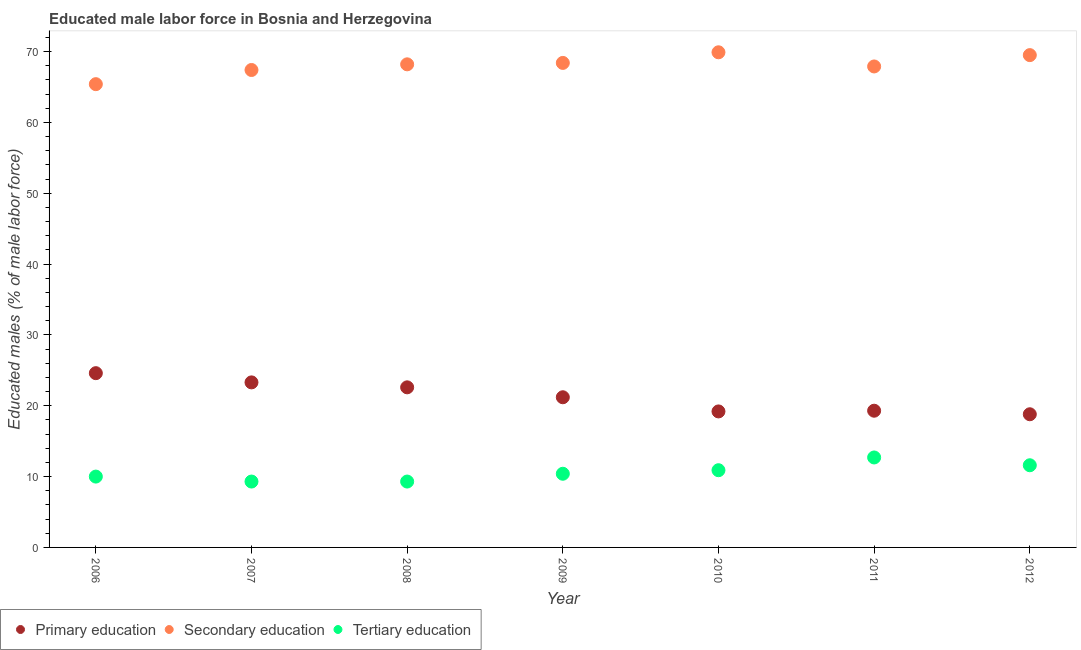How many different coloured dotlines are there?
Keep it short and to the point. 3. Is the number of dotlines equal to the number of legend labels?
Keep it short and to the point. Yes. What is the percentage of male labor force who received secondary education in 2006?
Provide a short and direct response. 65.4. Across all years, what is the maximum percentage of male labor force who received primary education?
Your answer should be very brief. 24.6. Across all years, what is the minimum percentage of male labor force who received secondary education?
Provide a succinct answer. 65.4. What is the total percentage of male labor force who received tertiary education in the graph?
Provide a short and direct response. 74.2. What is the difference between the percentage of male labor force who received secondary education in 2011 and that in 2012?
Your answer should be compact. -1.6. What is the difference between the percentage of male labor force who received secondary education in 2011 and the percentage of male labor force who received primary education in 2010?
Provide a short and direct response. 48.7. What is the average percentage of male labor force who received tertiary education per year?
Your answer should be compact. 10.6. In the year 2010, what is the difference between the percentage of male labor force who received secondary education and percentage of male labor force who received tertiary education?
Your response must be concise. 59. What is the ratio of the percentage of male labor force who received tertiary education in 2007 to that in 2012?
Make the answer very short. 0.8. What is the difference between the highest and the second highest percentage of male labor force who received primary education?
Give a very brief answer. 1.3. What is the difference between the highest and the lowest percentage of male labor force who received tertiary education?
Your answer should be very brief. 3.4. In how many years, is the percentage of male labor force who received tertiary education greater than the average percentage of male labor force who received tertiary education taken over all years?
Your response must be concise. 3. Is the percentage of male labor force who received secondary education strictly greater than the percentage of male labor force who received tertiary education over the years?
Your answer should be very brief. Yes. Is the percentage of male labor force who received primary education strictly less than the percentage of male labor force who received secondary education over the years?
Offer a very short reply. Yes. How many years are there in the graph?
Ensure brevity in your answer.  7. Does the graph contain grids?
Your answer should be very brief. No. Where does the legend appear in the graph?
Your answer should be very brief. Bottom left. How many legend labels are there?
Keep it short and to the point. 3. How are the legend labels stacked?
Offer a terse response. Horizontal. What is the title of the graph?
Ensure brevity in your answer.  Educated male labor force in Bosnia and Herzegovina. What is the label or title of the Y-axis?
Keep it short and to the point. Educated males (% of male labor force). What is the Educated males (% of male labor force) in Primary education in 2006?
Offer a terse response. 24.6. What is the Educated males (% of male labor force) in Secondary education in 2006?
Give a very brief answer. 65.4. What is the Educated males (% of male labor force) in Primary education in 2007?
Provide a short and direct response. 23.3. What is the Educated males (% of male labor force) in Secondary education in 2007?
Make the answer very short. 67.4. What is the Educated males (% of male labor force) of Tertiary education in 2007?
Make the answer very short. 9.3. What is the Educated males (% of male labor force) of Primary education in 2008?
Your response must be concise. 22.6. What is the Educated males (% of male labor force) in Secondary education in 2008?
Provide a short and direct response. 68.2. What is the Educated males (% of male labor force) of Tertiary education in 2008?
Provide a short and direct response. 9.3. What is the Educated males (% of male labor force) in Primary education in 2009?
Offer a terse response. 21.2. What is the Educated males (% of male labor force) of Secondary education in 2009?
Give a very brief answer. 68.4. What is the Educated males (% of male labor force) of Tertiary education in 2009?
Give a very brief answer. 10.4. What is the Educated males (% of male labor force) of Primary education in 2010?
Make the answer very short. 19.2. What is the Educated males (% of male labor force) of Secondary education in 2010?
Ensure brevity in your answer.  69.9. What is the Educated males (% of male labor force) of Tertiary education in 2010?
Keep it short and to the point. 10.9. What is the Educated males (% of male labor force) of Primary education in 2011?
Ensure brevity in your answer.  19.3. What is the Educated males (% of male labor force) in Secondary education in 2011?
Give a very brief answer. 67.9. What is the Educated males (% of male labor force) in Tertiary education in 2011?
Keep it short and to the point. 12.7. What is the Educated males (% of male labor force) of Primary education in 2012?
Your answer should be compact. 18.8. What is the Educated males (% of male labor force) in Secondary education in 2012?
Give a very brief answer. 69.5. What is the Educated males (% of male labor force) in Tertiary education in 2012?
Provide a succinct answer. 11.6. Across all years, what is the maximum Educated males (% of male labor force) in Primary education?
Make the answer very short. 24.6. Across all years, what is the maximum Educated males (% of male labor force) in Secondary education?
Keep it short and to the point. 69.9. Across all years, what is the maximum Educated males (% of male labor force) of Tertiary education?
Make the answer very short. 12.7. Across all years, what is the minimum Educated males (% of male labor force) of Primary education?
Keep it short and to the point. 18.8. Across all years, what is the minimum Educated males (% of male labor force) of Secondary education?
Your answer should be very brief. 65.4. Across all years, what is the minimum Educated males (% of male labor force) of Tertiary education?
Keep it short and to the point. 9.3. What is the total Educated males (% of male labor force) in Primary education in the graph?
Provide a short and direct response. 149. What is the total Educated males (% of male labor force) of Secondary education in the graph?
Offer a terse response. 476.7. What is the total Educated males (% of male labor force) of Tertiary education in the graph?
Your answer should be compact. 74.2. What is the difference between the Educated males (% of male labor force) of Tertiary education in 2006 and that in 2007?
Offer a terse response. 0.7. What is the difference between the Educated males (% of male labor force) of Primary education in 2006 and that in 2009?
Your answer should be compact. 3.4. What is the difference between the Educated males (% of male labor force) of Secondary education in 2006 and that in 2009?
Offer a terse response. -3. What is the difference between the Educated males (% of male labor force) in Tertiary education in 2006 and that in 2009?
Ensure brevity in your answer.  -0.4. What is the difference between the Educated males (% of male labor force) in Primary education in 2006 and that in 2010?
Your answer should be very brief. 5.4. What is the difference between the Educated males (% of male labor force) of Primary education in 2006 and that in 2011?
Provide a succinct answer. 5.3. What is the difference between the Educated males (% of male labor force) of Tertiary education in 2006 and that in 2011?
Provide a succinct answer. -2.7. What is the difference between the Educated males (% of male labor force) of Primary education in 2006 and that in 2012?
Make the answer very short. 5.8. What is the difference between the Educated males (% of male labor force) of Secondary education in 2006 and that in 2012?
Ensure brevity in your answer.  -4.1. What is the difference between the Educated males (% of male labor force) in Tertiary education in 2006 and that in 2012?
Provide a short and direct response. -1.6. What is the difference between the Educated males (% of male labor force) in Secondary education in 2007 and that in 2008?
Keep it short and to the point. -0.8. What is the difference between the Educated males (% of male labor force) of Tertiary education in 2007 and that in 2008?
Ensure brevity in your answer.  0. What is the difference between the Educated males (% of male labor force) of Secondary education in 2007 and that in 2009?
Your response must be concise. -1. What is the difference between the Educated males (% of male labor force) of Primary education in 2007 and that in 2010?
Your response must be concise. 4.1. What is the difference between the Educated males (% of male labor force) of Secondary education in 2007 and that in 2010?
Your response must be concise. -2.5. What is the difference between the Educated males (% of male labor force) in Tertiary education in 2007 and that in 2010?
Keep it short and to the point. -1.6. What is the difference between the Educated males (% of male labor force) of Primary education in 2007 and that in 2011?
Offer a terse response. 4. What is the difference between the Educated males (% of male labor force) of Primary education in 2007 and that in 2012?
Offer a terse response. 4.5. What is the difference between the Educated males (% of male labor force) of Secondary education in 2007 and that in 2012?
Offer a terse response. -2.1. What is the difference between the Educated males (% of male labor force) in Secondary education in 2008 and that in 2009?
Ensure brevity in your answer.  -0.2. What is the difference between the Educated males (% of male labor force) of Primary education in 2008 and that in 2012?
Your answer should be compact. 3.8. What is the difference between the Educated males (% of male labor force) of Secondary education in 2008 and that in 2012?
Give a very brief answer. -1.3. What is the difference between the Educated males (% of male labor force) of Secondary education in 2009 and that in 2010?
Keep it short and to the point. -1.5. What is the difference between the Educated males (% of male labor force) in Tertiary education in 2009 and that in 2010?
Offer a very short reply. -0.5. What is the difference between the Educated males (% of male labor force) of Tertiary education in 2009 and that in 2012?
Make the answer very short. -1.2. What is the difference between the Educated males (% of male labor force) of Tertiary education in 2010 and that in 2011?
Give a very brief answer. -1.8. What is the difference between the Educated males (% of male labor force) in Primary education in 2010 and that in 2012?
Keep it short and to the point. 0.4. What is the difference between the Educated males (% of male labor force) of Secondary education in 2010 and that in 2012?
Your response must be concise. 0.4. What is the difference between the Educated males (% of male labor force) in Tertiary education in 2010 and that in 2012?
Keep it short and to the point. -0.7. What is the difference between the Educated males (% of male labor force) of Primary education in 2006 and the Educated males (% of male labor force) of Secondary education in 2007?
Your answer should be very brief. -42.8. What is the difference between the Educated males (% of male labor force) in Primary education in 2006 and the Educated males (% of male labor force) in Tertiary education in 2007?
Provide a succinct answer. 15.3. What is the difference between the Educated males (% of male labor force) in Secondary education in 2006 and the Educated males (% of male labor force) in Tertiary education in 2007?
Your response must be concise. 56.1. What is the difference between the Educated males (% of male labor force) of Primary education in 2006 and the Educated males (% of male labor force) of Secondary education in 2008?
Keep it short and to the point. -43.6. What is the difference between the Educated males (% of male labor force) of Secondary education in 2006 and the Educated males (% of male labor force) of Tertiary education in 2008?
Your answer should be very brief. 56.1. What is the difference between the Educated males (% of male labor force) of Primary education in 2006 and the Educated males (% of male labor force) of Secondary education in 2009?
Give a very brief answer. -43.8. What is the difference between the Educated males (% of male labor force) of Primary education in 2006 and the Educated males (% of male labor force) of Tertiary education in 2009?
Offer a terse response. 14.2. What is the difference between the Educated males (% of male labor force) in Secondary education in 2006 and the Educated males (% of male labor force) in Tertiary education in 2009?
Give a very brief answer. 55. What is the difference between the Educated males (% of male labor force) in Primary education in 2006 and the Educated males (% of male labor force) in Secondary education in 2010?
Keep it short and to the point. -45.3. What is the difference between the Educated males (% of male labor force) of Primary education in 2006 and the Educated males (% of male labor force) of Tertiary education in 2010?
Provide a succinct answer. 13.7. What is the difference between the Educated males (% of male labor force) of Secondary education in 2006 and the Educated males (% of male labor force) of Tertiary education in 2010?
Provide a short and direct response. 54.5. What is the difference between the Educated males (% of male labor force) of Primary education in 2006 and the Educated males (% of male labor force) of Secondary education in 2011?
Make the answer very short. -43.3. What is the difference between the Educated males (% of male labor force) of Secondary education in 2006 and the Educated males (% of male labor force) of Tertiary education in 2011?
Provide a short and direct response. 52.7. What is the difference between the Educated males (% of male labor force) of Primary education in 2006 and the Educated males (% of male labor force) of Secondary education in 2012?
Make the answer very short. -44.9. What is the difference between the Educated males (% of male labor force) in Secondary education in 2006 and the Educated males (% of male labor force) in Tertiary education in 2012?
Offer a terse response. 53.8. What is the difference between the Educated males (% of male labor force) of Primary education in 2007 and the Educated males (% of male labor force) of Secondary education in 2008?
Your answer should be compact. -44.9. What is the difference between the Educated males (% of male labor force) of Secondary education in 2007 and the Educated males (% of male labor force) of Tertiary education in 2008?
Your answer should be very brief. 58.1. What is the difference between the Educated males (% of male labor force) of Primary education in 2007 and the Educated males (% of male labor force) of Secondary education in 2009?
Give a very brief answer. -45.1. What is the difference between the Educated males (% of male labor force) in Primary education in 2007 and the Educated males (% of male labor force) in Tertiary education in 2009?
Give a very brief answer. 12.9. What is the difference between the Educated males (% of male labor force) in Secondary education in 2007 and the Educated males (% of male labor force) in Tertiary education in 2009?
Offer a very short reply. 57. What is the difference between the Educated males (% of male labor force) of Primary education in 2007 and the Educated males (% of male labor force) of Secondary education in 2010?
Provide a succinct answer. -46.6. What is the difference between the Educated males (% of male labor force) of Primary education in 2007 and the Educated males (% of male labor force) of Tertiary education in 2010?
Offer a terse response. 12.4. What is the difference between the Educated males (% of male labor force) of Secondary education in 2007 and the Educated males (% of male labor force) of Tertiary education in 2010?
Provide a short and direct response. 56.5. What is the difference between the Educated males (% of male labor force) in Primary education in 2007 and the Educated males (% of male labor force) in Secondary education in 2011?
Your answer should be very brief. -44.6. What is the difference between the Educated males (% of male labor force) in Primary education in 2007 and the Educated males (% of male labor force) in Tertiary education in 2011?
Provide a short and direct response. 10.6. What is the difference between the Educated males (% of male labor force) in Secondary education in 2007 and the Educated males (% of male labor force) in Tertiary education in 2011?
Give a very brief answer. 54.7. What is the difference between the Educated males (% of male labor force) in Primary education in 2007 and the Educated males (% of male labor force) in Secondary education in 2012?
Your answer should be compact. -46.2. What is the difference between the Educated males (% of male labor force) of Secondary education in 2007 and the Educated males (% of male labor force) of Tertiary education in 2012?
Provide a short and direct response. 55.8. What is the difference between the Educated males (% of male labor force) in Primary education in 2008 and the Educated males (% of male labor force) in Secondary education in 2009?
Offer a very short reply. -45.8. What is the difference between the Educated males (% of male labor force) of Secondary education in 2008 and the Educated males (% of male labor force) of Tertiary education in 2009?
Ensure brevity in your answer.  57.8. What is the difference between the Educated males (% of male labor force) in Primary education in 2008 and the Educated males (% of male labor force) in Secondary education in 2010?
Make the answer very short. -47.3. What is the difference between the Educated males (% of male labor force) of Primary education in 2008 and the Educated males (% of male labor force) of Tertiary education in 2010?
Your answer should be very brief. 11.7. What is the difference between the Educated males (% of male labor force) in Secondary education in 2008 and the Educated males (% of male labor force) in Tertiary education in 2010?
Offer a terse response. 57.3. What is the difference between the Educated males (% of male labor force) of Primary education in 2008 and the Educated males (% of male labor force) of Secondary education in 2011?
Provide a succinct answer. -45.3. What is the difference between the Educated males (% of male labor force) in Secondary education in 2008 and the Educated males (% of male labor force) in Tertiary education in 2011?
Ensure brevity in your answer.  55.5. What is the difference between the Educated males (% of male labor force) in Primary education in 2008 and the Educated males (% of male labor force) in Secondary education in 2012?
Offer a terse response. -46.9. What is the difference between the Educated males (% of male labor force) of Primary education in 2008 and the Educated males (% of male labor force) of Tertiary education in 2012?
Offer a terse response. 11. What is the difference between the Educated males (% of male labor force) in Secondary education in 2008 and the Educated males (% of male labor force) in Tertiary education in 2012?
Your answer should be compact. 56.6. What is the difference between the Educated males (% of male labor force) in Primary education in 2009 and the Educated males (% of male labor force) in Secondary education in 2010?
Provide a short and direct response. -48.7. What is the difference between the Educated males (% of male labor force) of Secondary education in 2009 and the Educated males (% of male labor force) of Tertiary education in 2010?
Provide a short and direct response. 57.5. What is the difference between the Educated males (% of male labor force) of Primary education in 2009 and the Educated males (% of male labor force) of Secondary education in 2011?
Give a very brief answer. -46.7. What is the difference between the Educated males (% of male labor force) in Secondary education in 2009 and the Educated males (% of male labor force) in Tertiary education in 2011?
Make the answer very short. 55.7. What is the difference between the Educated males (% of male labor force) in Primary education in 2009 and the Educated males (% of male labor force) in Secondary education in 2012?
Provide a succinct answer. -48.3. What is the difference between the Educated males (% of male labor force) in Secondary education in 2009 and the Educated males (% of male labor force) in Tertiary education in 2012?
Provide a succinct answer. 56.8. What is the difference between the Educated males (% of male labor force) in Primary education in 2010 and the Educated males (% of male labor force) in Secondary education in 2011?
Your answer should be very brief. -48.7. What is the difference between the Educated males (% of male labor force) of Primary education in 2010 and the Educated males (% of male labor force) of Tertiary education in 2011?
Give a very brief answer. 6.5. What is the difference between the Educated males (% of male labor force) of Secondary education in 2010 and the Educated males (% of male labor force) of Tertiary education in 2011?
Your answer should be very brief. 57.2. What is the difference between the Educated males (% of male labor force) in Primary education in 2010 and the Educated males (% of male labor force) in Secondary education in 2012?
Offer a terse response. -50.3. What is the difference between the Educated males (% of male labor force) in Primary education in 2010 and the Educated males (% of male labor force) in Tertiary education in 2012?
Offer a terse response. 7.6. What is the difference between the Educated males (% of male labor force) of Secondary education in 2010 and the Educated males (% of male labor force) of Tertiary education in 2012?
Your answer should be compact. 58.3. What is the difference between the Educated males (% of male labor force) of Primary education in 2011 and the Educated males (% of male labor force) of Secondary education in 2012?
Offer a terse response. -50.2. What is the difference between the Educated males (% of male labor force) in Secondary education in 2011 and the Educated males (% of male labor force) in Tertiary education in 2012?
Make the answer very short. 56.3. What is the average Educated males (% of male labor force) of Primary education per year?
Make the answer very short. 21.29. What is the average Educated males (% of male labor force) of Secondary education per year?
Your answer should be compact. 68.1. What is the average Educated males (% of male labor force) in Tertiary education per year?
Your response must be concise. 10.6. In the year 2006, what is the difference between the Educated males (% of male labor force) of Primary education and Educated males (% of male labor force) of Secondary education?
Your answer should be very brief. -40.8. In the year 2006, what is the difference between the Educated males (% of male labor force) of Secondary education and Educated males (% of male labor force) of Tertiary education?
Make the answer very short. 55.4. In the year 2007, what is the difference between the Educated males (% of male labor force) of Primary education and Educated males (% of male labor force) of Secondary education?
Provide a succinct answer. -44.1. In the year 2007, what is the difference between the Educated males (% of male labor force) in Primary education and Educated males (% of male labor force) in Tertiary education?
Ensure brevity in your answer.  14. In the year 2007, what is the difference between the Educated males (% of male labor force) of Secondary education and Educated males (% of male labor force) of Tertiary education?
Offer a very short reply. 58.1. In the year 2008, what is the difference between the Educated males (% of male labor force) in Primary education and Educated males (% of male labor force) in Secondary education?
Provide a succinct answer. -45.6. In the year 2008, what is the difference between the Educated males (% of male labor force) in Secondary education and Educated males (% of male labor force) in Tertiary education?
Provide a short and direct response. 58.9. In the year 2009, what is the difference between the Educated males (% of male labor force) in Primary education and Educated males (% of male labor force) in Secondary education?
Your answer should be compact. -47.2. In the year 2009, what is the difference between the Educated males (% of male labor force) of Primary education and Educated males (% of male labor force) of Tertiary education?
Your answer should be very brief. 10.8. In the year 2009, what is the difference between the Educated males (% of male labor force) of Secondary education and Educated males (% of male labor force) of Tertiary education?
Keep it short and to the point. 58. In the year 2010, what is the difference between the Educated males (% of male labor force) in Primary education and Educated males (% of male labor force) in Secondary education?
Ensure brevity in your answer.  -50.7. In the year 2010, what is the difference between the Educated males (% of male labor force) of Secondary education and Educated males (% of male labor force) of Tertiary education?
Ensure brevity in your answer.  59. In the year 2011, what is the difference between the Educated males (% of male labor force) in Primary education and Educated males (% of male labor force) in Secondary education?
Ensure brevity in your answer.  -48.6. In the year 2011, what is the difference between the Educated males (% of male labor force) in Secondary education and Educated males (% of male labor force) in Tertiary education?
Offer a very short reply. 55.2. In the year 2012, what is the difference between the Educated males (% of male labor force) in Primary education and Educated males (% of male labor force) in Secondary education?
Your answer should be compact. -50.7. In the year 2012, what is the difference between the Educated males (% of male labor force) of Primary education and Educated males (% of male labor force) of Tertiary education?
Your answer should be compact. 7.2. In the year 2012, what is the difference between the Educated males (% of male labor force) of Secondary education and Educated males (% of male labor force) of Tertiary education?
Your answer should be compact. 57.9. What is the ratio of the Educated males (% of male labor force) in Primary education in 2006 to that in 2007?
Your answer should be very brief. 1.06. What is the ratio of the Educated males (% of male labor force) of Secondary education in 2006 to that in 2007?
Keep it short and to the point. 0.97. What is the ratio of the Educated males (% of male labor force) in Tertiary education in 2006 to that in 2007?
Your response must be concise. 1.08. What is the ratio of the Educated males (% of male labor force) in Primary education in 2006 to that in 2008?
Your response must be concise. 1.09. What is the ratio of the Educated males (% of male labor force) in Secondary education in 2006 to that in 2008?
Provide a succinct answer. 0.96. What is the ratio of the Educated males (% of male labor force) in Tertiary education in 2006 to that in 2008?
Your response must be concise. 1.08. What is the ratio of the Educated males (% of male labor force) of Primary education in 2006 to that in 2009?
Offer a very short reply. 1.16. What is the ratio of the Educated males (% of male labor force) of Secondary education in 2006 to that in 2009?
Give a very brief answer. 0.96. What is the ratio of the Educated males (% of male labor force) in Tertiary education in 2006 to that in 2009?
Your response must be concise. 0.96. What is the ratio of the Educated males (% of male labor force) in Primary education in 2006 to that in 2010?
Provide a succinct answer. 1.28. What is the ratio of the Educated males (% of male labor force) in Secondary education in 2006 to that in 2010?
Make the answer very short. 0.94. What is the ratio of the Educated males (% of male labor force) in Tertiary education in 2006 to that in 2010?
Ensure brevity in your answer.  0.92. What is the ratio of the Educated males (% of male labor force) of Primary education in 2006 to that in 2011?
Make the answer very short. 1.27. What is the ratio of the Educated males (% of male labor force) of Secondary education in 2006 to that in 2011?
Your answer should be compact. 0.96. What is the ratio of the Educated males (% of male labor force) of Tertiary education in 2006 to that in 2011?
Keep it short and to the point. 0.79. What is the ratio of the Educated males (% of male labor force) of Primary education in 2006 to that in 2012?
Your answer should be very brief. 1.31. What is the ratio of the Educated males (% of male labor force) of Secondary education in 2006 to that in 2012?
Provide a short and direct response. 0.94. What is the ratio of the Educated males (% of male labor force) of Tertiary education in 2006 to that in 2012?
Your response must be concise. 0.86. What is the ratio of the Educated males (% of male labor force) in Primary education in 2007 to that in 2008?
Your answer should be very brief. 1.03. What is the ratio of the Educated males (% of male labor force) of Secondary education in 2007 to that in 2008?
Offer a very short reply. 0.99. What is the ratio of the Educated males (% of male labor force) of Tertiary education in 2007 to that in 2008?
Ensure brevity in your answer.  1. What is the ratio of the Educated males (% of male labor force) of Primary education in 2007 to that in 2009?
Offer a very short reply. 1.1. What is the ratio of the Educated males (% of male labor force) of Secondary education in 2007 to that in 2009?
Give a very brief answer. 0.99. What is the ratio of the Educated males (% of male labor force) in Tertiary education in 2007 to that in 2009?
Your response must be concise. 0.89. What is the ratio of the Educated males (% of male labor force) of Primary education in 2007 to that in 2010?
Your answer should be compact. 1.21. What is the ratio of the Educated males (% of male labor force) in Secondary education in 2007 to that in 2010?
Offer a very short reply. 0.96. What is the ratio of the Educated males (% of male labor force) of Tertiary education in 2007 to that in 2010?
Your response must be concise. 0.85. What is the ratio of the Educated males (% of male labor force) in Primary education in 2007 to that in 2011?
Provide a short and direct response. 1.21. What is the ratio of the Educated males (% of male labor force) in Secondary education in 2007 to that in 2011?
Ensure brevity in your answer.  0.99. What is the ratio of the Educated males (% of male labor force) in Tertiary education in 2007 to that in 2011?
Make the answer very short. 0.73. What is the ratio of the Educated males (% of male labor force) in Primary education in 2007 to that in 2012?
Your answer should be very brief. 1.24. What is the ratio of the Educated males (% of male labor force) of Secondary education in 2007 to that in 2012?
Provide a short and direct response. 0.97. What is the ratio of the Educated males (% of male labor force) in Tertiary education in 2007 to that in 2012?
Ensure brevity in your answer.  0.8. What is the ratio of the Educated males (% of male labor force) of Primary education in 2008 to that in 2009?
Offer a very short reply. 1.07. What is the ratio of the Educated males (% of male labor force) in Secondary education in 2008 to that in 2009?
Provide a short and direct response. 1. What is the ratio of the Educated males (% of male labor force) in Tertiary education in 2008 to that in 2009?
Keep it short and to the point. 0.89. What is the ratio of the Educated males (% of male labor force) of Primary education in 2008 to that in 2010?
Offer a terse response. 1.18. What is the ratio of the Educated males (% of male labor force) in Secondary education in 2008 to that in 2010?
Your response must be concise. 0.98. What is the ratio of the Educated males (% of male labor force) in Tertiary education in 2008 to that in 2010?
Your response must be concise. 0.85. What is the ratio of the Educated males (% of male labor force) of Primary education in 2008 to that in 2011?
Offer a very short reply. 1.17. What is the ratio of the Educated males (% of male labor force) of Secondary education in 2008 to that in 2011?
Offer a very short reply. 1. What is the ratio of the Educated males (% of male labor force) of Tertiary education in 2008 to that in 2011?
Offer a very short reply. 0.73. What is the ratio of the Educated males (% of male labor force) of Primary education in 2008 to that in 2012?
Your answer should be compact. 1.2. What is the ratio of the Educated males (% of male labor force) of Secondary education in 2008 to that in 2012?
Offer a terse response. 0.98. What is the ratio of the Educated males (% of male labor force) in Tertiary education in 2008 to that in 2012?
Give a very brief answer. 0.8. What is the ratio of the Educated males (% of male labor force) of Primary education in 2009 to that in 2010?
Offer a very short reply. 1.1. What is the ratio of the Educated males (% of male labor force) of Secondary education in 2009 to that in 2010?
Make the answer very short. 0.98. What is the ratio of the Educated males (% of male labor force) in Tertiary education in 2009 to that in 2010?
Provide a succinct answer. 0.95. What is the ratio of the Educated males (% of male labor force) in Primary education in 2009 to that in 2011?
Keep it short and to the point. 1.1. What is the ratio of the Educated males (% of male labor force) of Secondary education in 2009 to that in 2011?
Offer a terse response. 1.01. What is the ratio of the Educated males (% of male labor force) of Tertiary education in 2009 to that in 2011?
Make the answer very short. 0.82. What is the ratio of the Educated males (% of male labor force) of Primary education in 2009 to that in 2012?
Make the answer very short. 1.13. What is the ratio of the Educated males (% of male labor force) of Secondary education in 2009 to that in 2012?
Your answer should be compact. 0.98. What is the ratio of the Educated males (% of male labor force) of Tertiary education in 2009 to that in 2012?
Make the answer very short. 0.9. What is the ratio of the Educated males (% of male labor force) of Primary education in 2010 to that in 2011?
Offer a terse response. 0.99. What is the ratio of the Educated males (% of male labor force) in Secondary education in 2010 to that in 2011?
Ensure brevity in your answer.  1.03. What is the ratio of the Educated males (% of male labor force) in Tertiary education in 2010 to that in 2011?
Provide a short and direct response. 0.86. What is the ratio of the Educated males (% of male labor force) in Primary education in 2010 to that in 2012?
Your response must be concise. 1.02. What is the ratio of the Educated males (% of male labor force) in Secondary education in 2010 to that in 2012?
Provide a succinct answer. 1.01. What is the ratio of the Educated males (% of male labor force) of Tertiary education in 2010 to that in 2012?
Offer a terse response. 0.94. What is the ratio of the Educated males (% of male labor force) of Primary education in 2011 to that in 2012?
Your answer should be very brief. 1.03. What is the ratio of the Educated males (% of male labor force) of Secondary education in 2011 to that in 2012?
Offer a very short reply. 0.98. What is the ratio of the Educated males (% of male labor force) in Tertiary education in 2011 to that in 2012?
Make the answer very short. 1.09. What is the difference between the highest and the second highest Educated males (% of male labor force) in Primary education?
Offer a very short reply. 1.3. What is the difference between the highest and the second highest Educated males (% of male labor force) in Tertiary education?
Make the answer very short. 1.1. What is the difference between the highest and the lowest Educated males (% of male labor force) in Primary education?
Your response must be concise. 5.8. What is the difference between the highest and the lowest Educated males (% of male labor force) in Tertiary education?
Offer a very short reply. 3.4. 